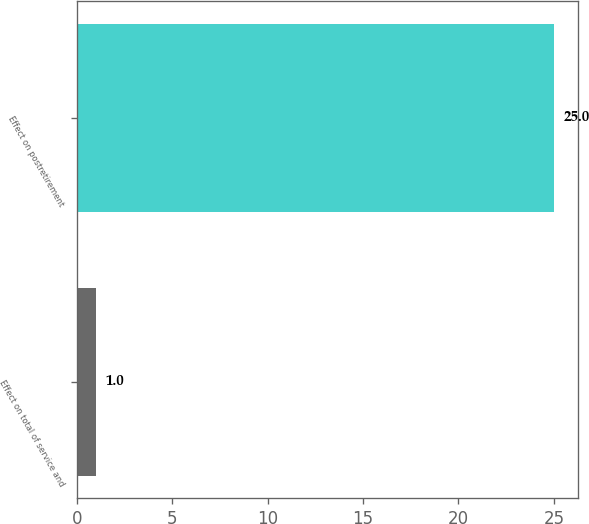<chart> <loc_0><loc_0><loc_500><loc_500><bar_chart><fcel>Effect on total of service and<fcel>Effect on postretirement<nl><fcel>1<fcel>25<nl></chart> 